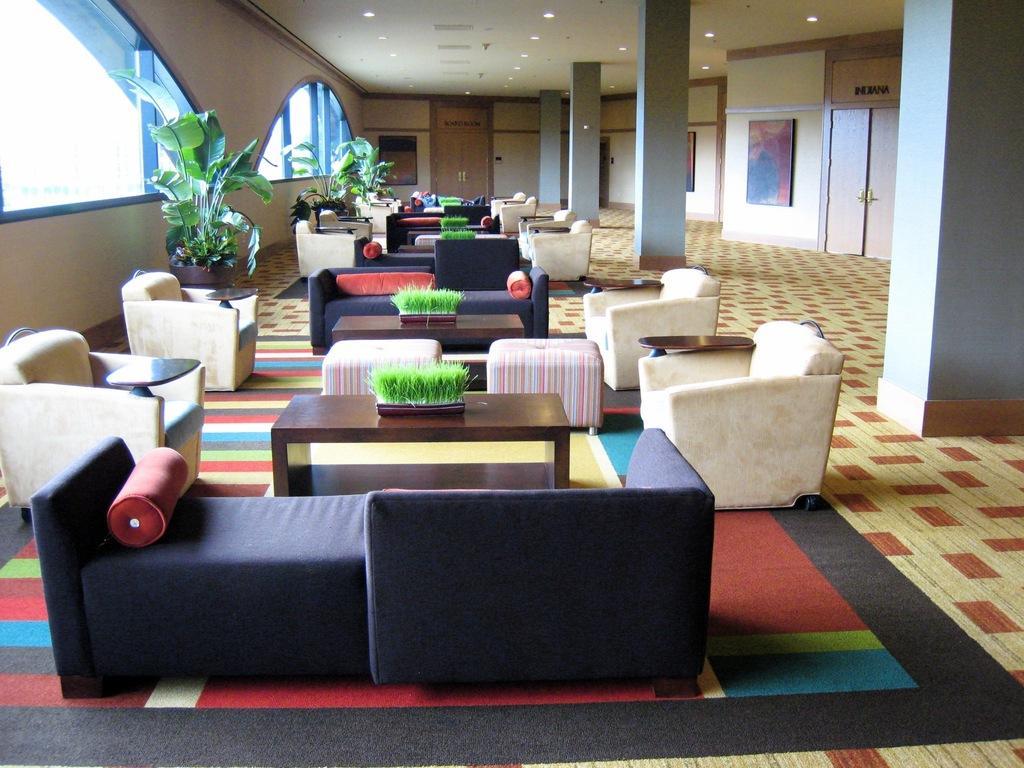Could you give a brief overview of what you see in this image? There is a waiting hall in this image with a carpet on the floor with a wall frame hanged on the wall. Lights on on the roof, there is a center table one,two,three,four and sofa set. There is a houseplant in the hall window there is a door. 